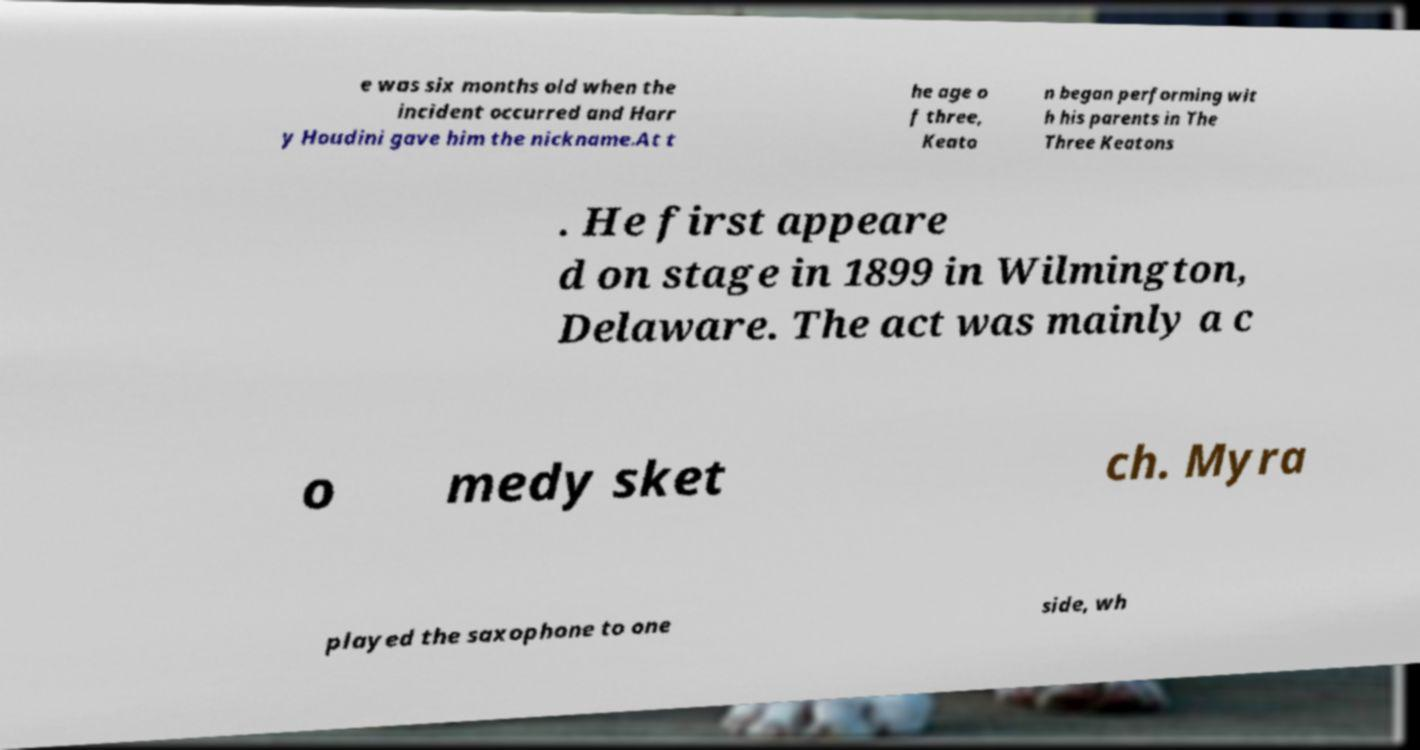Please read and relay the text visible in this image. What does it say? e was six months old when the incident occurred and Harr y Houdini gave him the nickname.At t he age o f three, Keato n began performing wit h his parents in The Three Keatons . He first appeare d on stage in 1899 in Wilmington, Delaware. The act was mainly a c o medy sket ch. Myra played the saxophone to one side, wh 